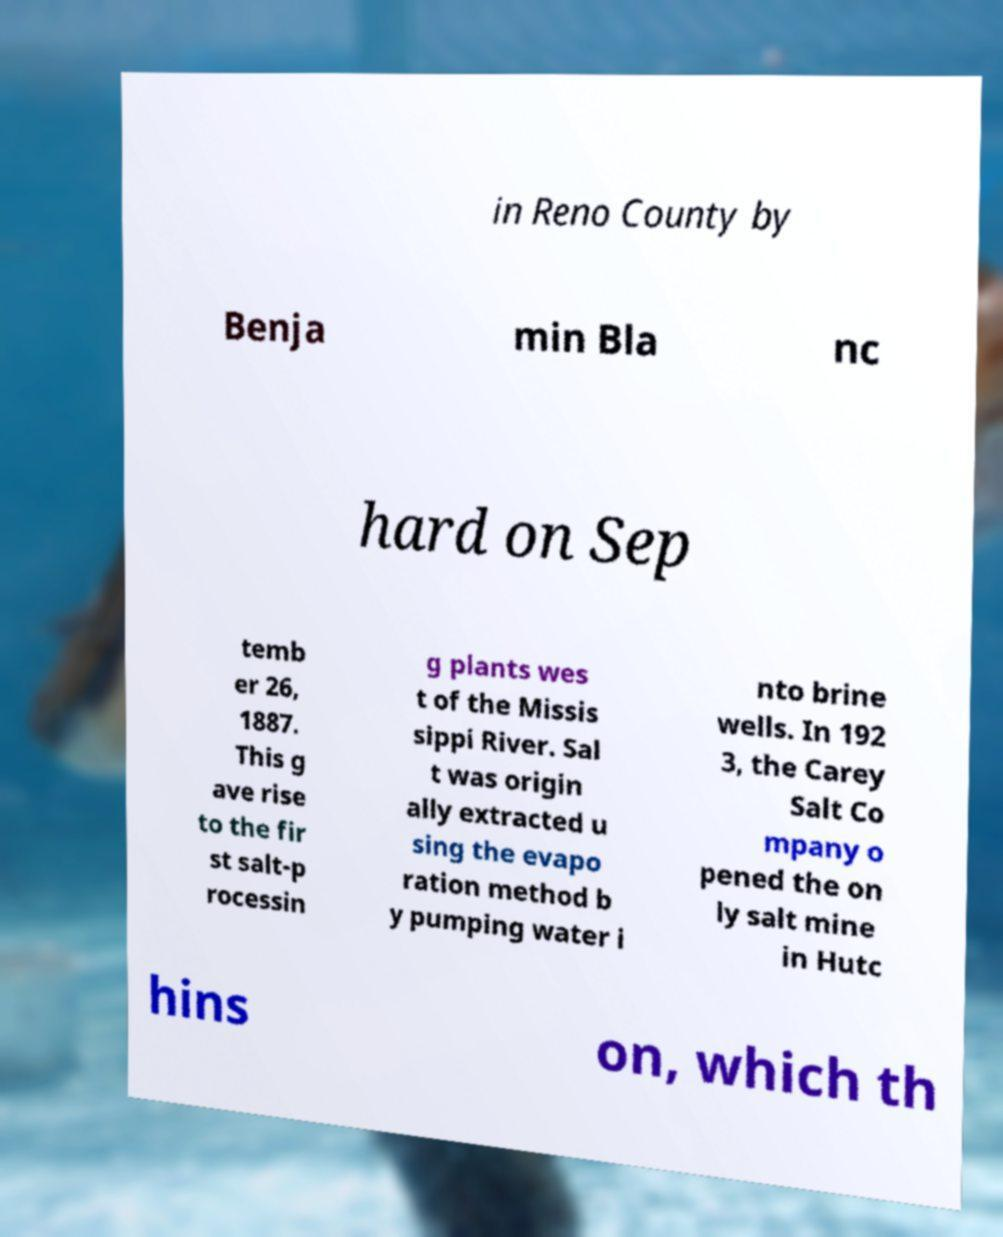There's text embedded in this image that I need extracted. Can you transcribe it verbatim? in Reno County by Benja min Bla nc hard on Sep temb er 26, 1887. This g ave rise to the fir st salt-p rocessin g plants wes t of the Missis sippi River. Sal t was origin ally extracted u sing the evapo ration method b y pumping water i nto brine wells. In 192 3, the Carey Salt Co mpany o pened the on ly salt mine in Hutc hins on, which th 